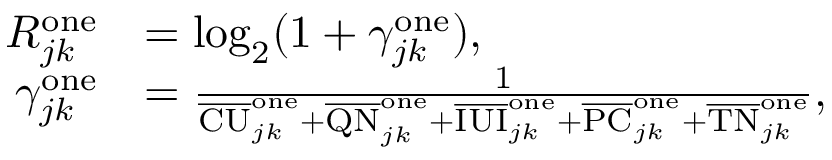Convert formula to latex. <formula><loc_0><loc_0><loc_500><loc_500>\begin{array} { r l } { R _ { j k } ^ { o n e } } & { = \log _ { 2 } ( 1 + \gamma _ { j k } ^ { o n e } ) , } \\ { \gamma _ { j k } ^ { o n e } } & { = \frac { 1 } { \overline { C U } _ { j k } ^ { o n e } + \overline { Q N } _ { j k } ^ { o n e } + \overline { I U I } _ { j k } ^ { o n e } + \overline { P C } _ { j k } ^ { o n e } + \overline { T N } _ { j k } ^ { o n e } } , } \end{array}</formula> 